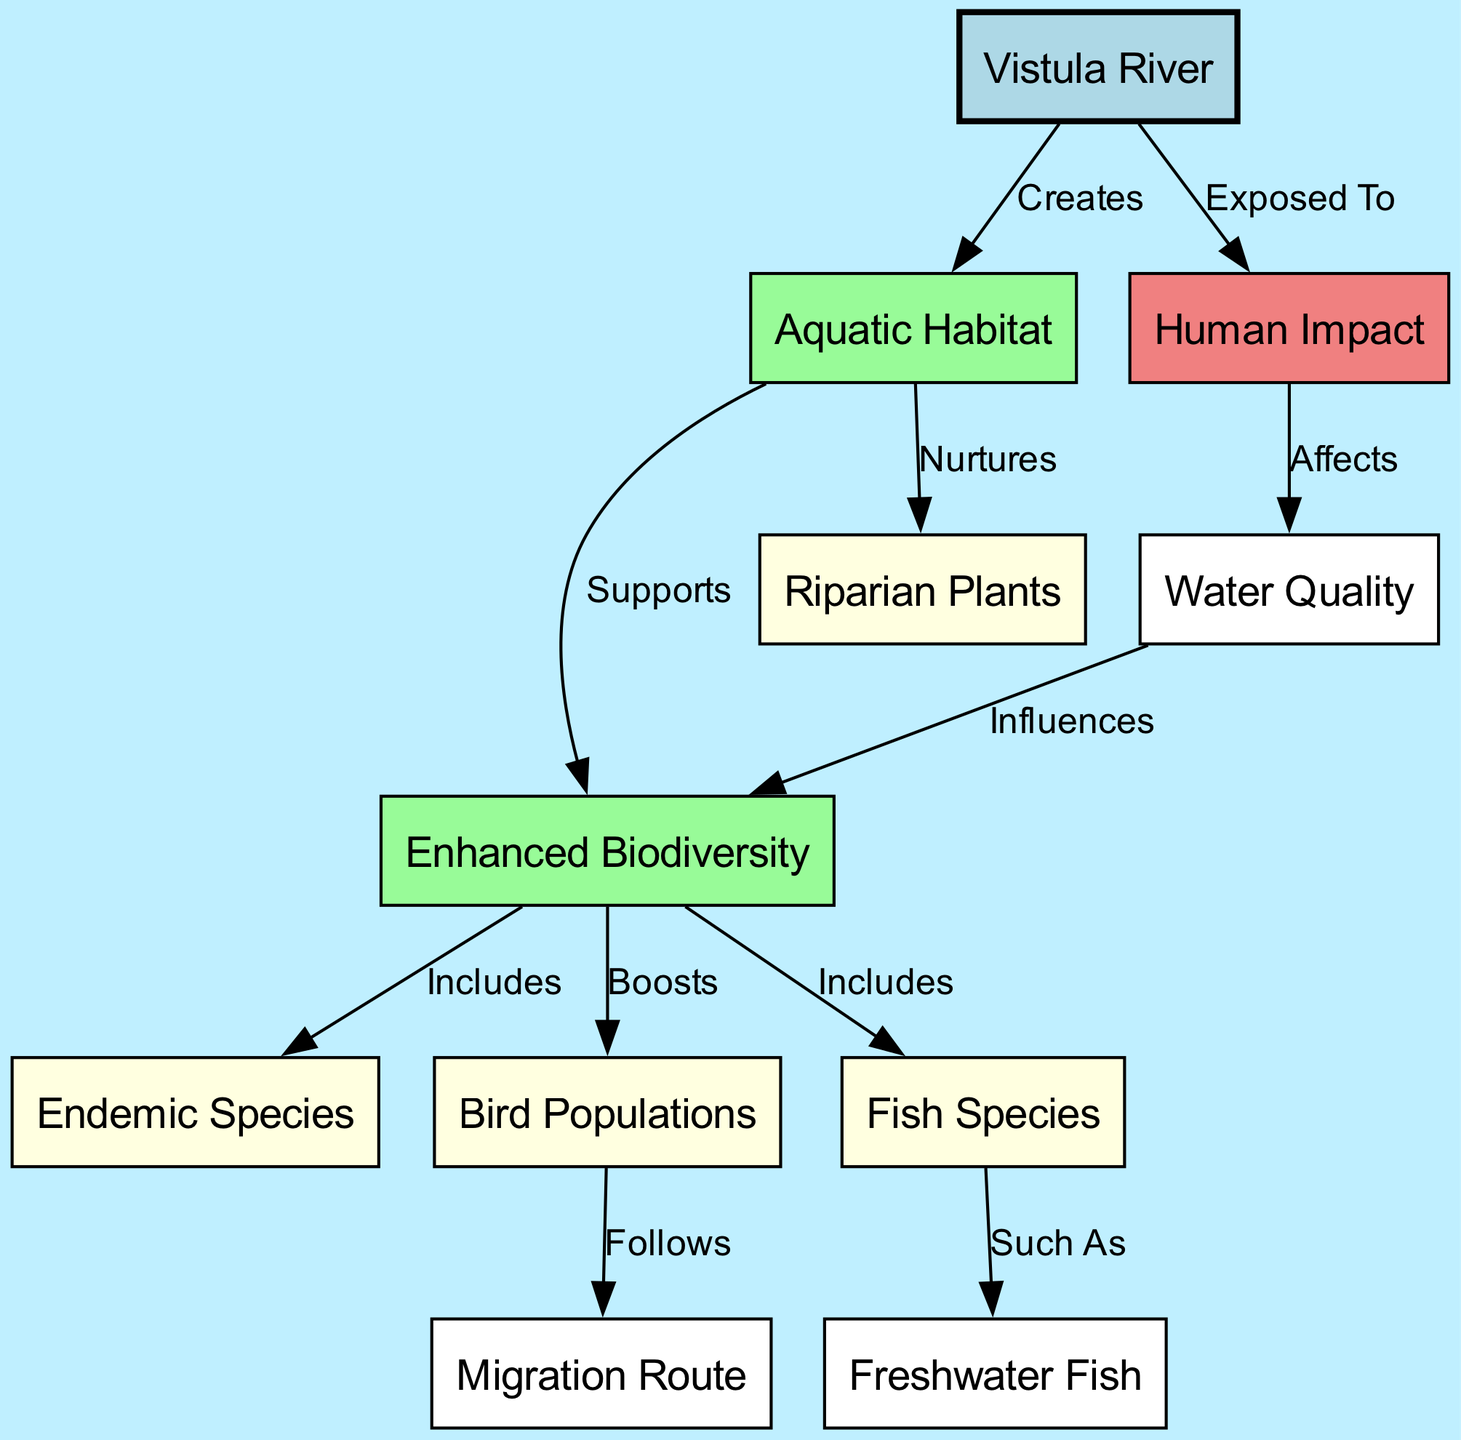What does the Vistula River create? The diagram shows that the Vistula River creates the Aquatic Habitat. This is directly indicated by the edge labeled "Creates" from the Vistula River node to the Aquatic Habitat node.
Answer: Aquatic Habitat How many species types are included in Biodiversity? The Biodiversity node connects to three specific types: Endemic Species, Bird Populations, and Fish Species. Thus, there are three species types highlighted as part of Biodiversity.
Answer: Three What influences biodiversity according to the diagram? The diagram illustrates that Water Quality influences Biodiversity. This relationship is shown with the directed edge from Water Quality to Biodiversity labeled "Influences".
Answer: Water Quality What effect does Human Impact have on Water Quality? The directed edge labeled "Affects" indicates that Human Impact has a negative effect on Water Quality. Therefore, according to the diagram, this specific relationship recognizes the impact that human activities can have on the quality of water in the ecosystem.
Answer: Affects Which populations follow the Migration Route? The diagram indicates that Bird Populations follow the Migration Route, as demonstrated by the connection labeled "Follows" between the Bird Populations node and the Migration Route node.
Answer: Bird Populations What are some examples of fish species included in biodiversity? The diagram specifies that Fish Species includes Freshwater Fish. Therefore, Freshwater Fish is a representative example that specifies the type of fish species included in the broader category of Biodiversity.
Answer: Freshwater Fish What do Riparian Plants receive support from? According to the diagram, Riparian Plants are nurtured by the Aquatic Habitat. The edge linked to Plants shows the label "Nurtures", indicating the support relationship they have with Aquatic Habitat.
Answer: Aquatic Habitat What is the relationship between Habitat and Biodiversity? The connection labeled "Supports" from the Habitat node to the Biodiversity node explicitly describes the relationship, indicating that the Aquatic Habitat supports the overall biodiversity in the ecosystem.
Answer: Supports How does Human Impact relate to the Vistula River? The diagram shows that Human Impact is something that the Vistula River is exposed to. This relationship is depicted with the edge labeled "Exposed To" linking the Vistula River and Human Impact nodes.
Answer: Exposed To 